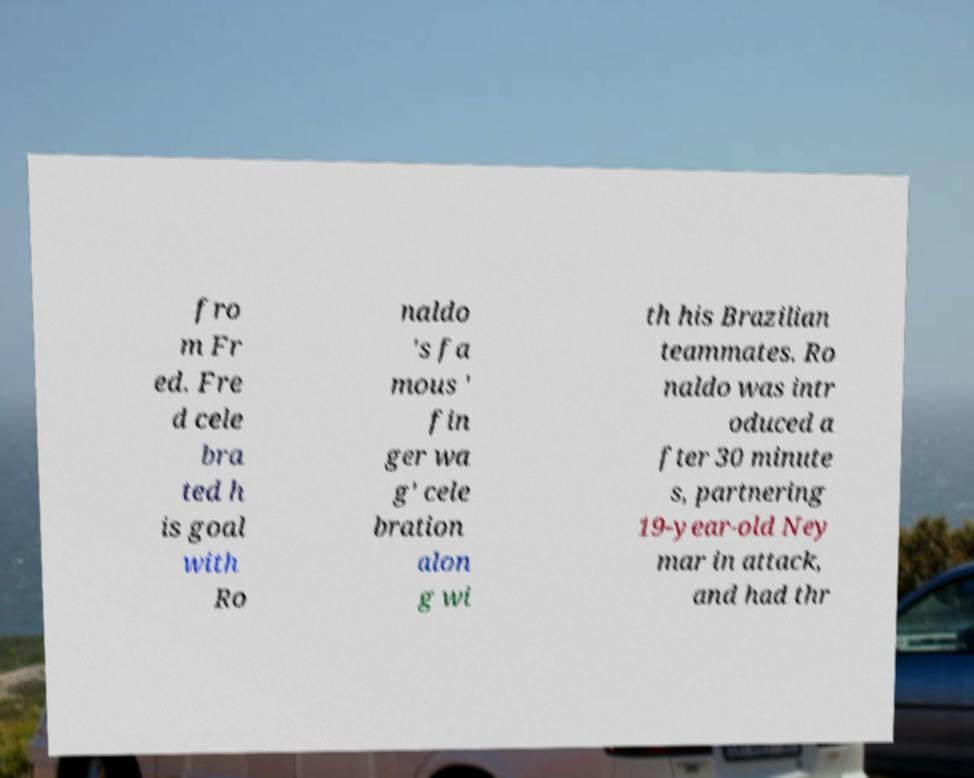Could you assist in decoding the text presented in this image and type it out clearly? fro m Fr ed. Fre d cele bra ted h is goal with Ro naldo 's fa mous ' fin ger wa g' cele bration alon g wi th his Brazilian teammates. Ro naldo was intr oduced a fter 30 minute s, partnering 19-year-old Ney mar in attack, and had thr 